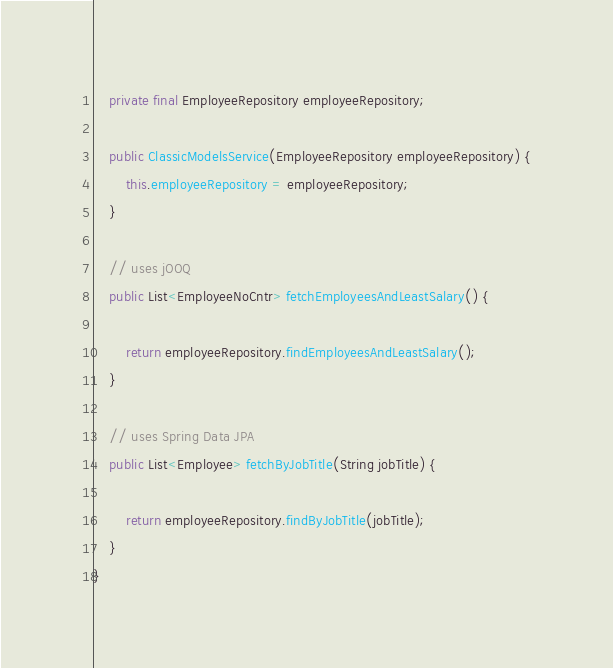<code> <loc_0><loc_0><loc_500><loc_500><_Java_>
    private final EmployeeRepository employeeRepository;

    public ClassicModelsService(EmployeeRepository employeeRepository) {
        this.employeeRepository = employeeRepository;
    }

    // uses jOOQ       
    public List<EmployeeNoCntr> fetchEmployeesAndLeastSalary() {

        return employeeRepository.findEmployeesAndLeastSalary();
    }

    // uses Spring Data JPA    
    public List<Employee> fetchByJobTitle(String jobTitle) {

        return employeeRepository.findByJobTitle(jobTitle);
    }
}
</code> 